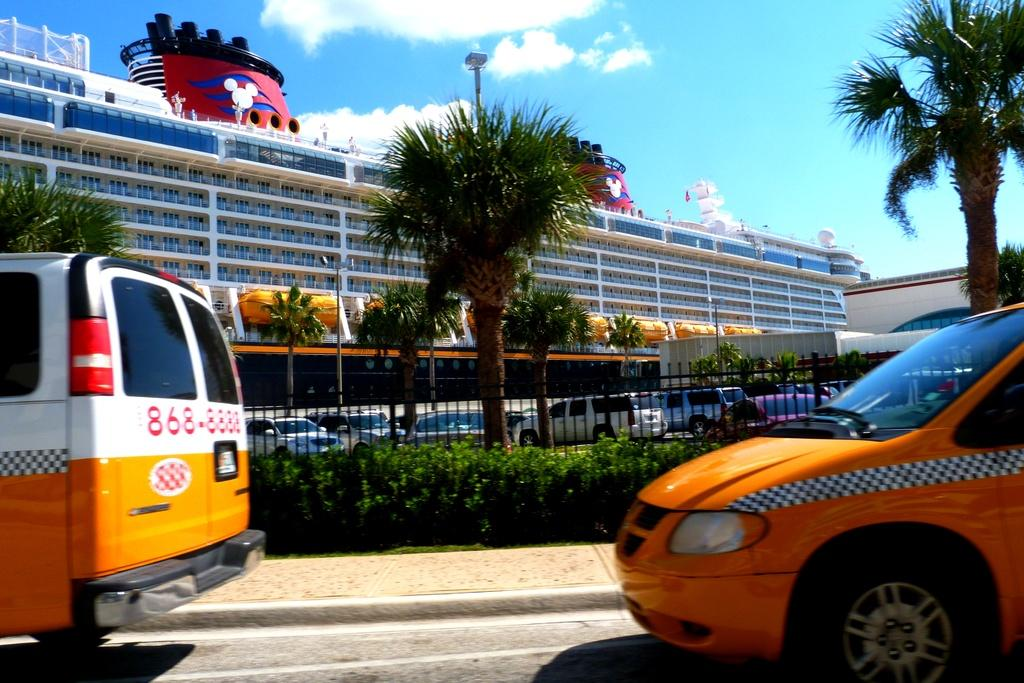<image>
Create a compact narrative representing the image presented. A taxi with the number 868-8888 on it driving past a cruise ship. 